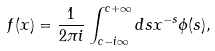Convert formula to latex. <formula><loc_0><loc_0><loc_500><loc_500>f ( x ) = \frac { 1 } { 2 \pi i } \int _ { c - i \infty } ^ { c + \infty } d s x ^ { - s } \phi ( s ) ,</formula> 